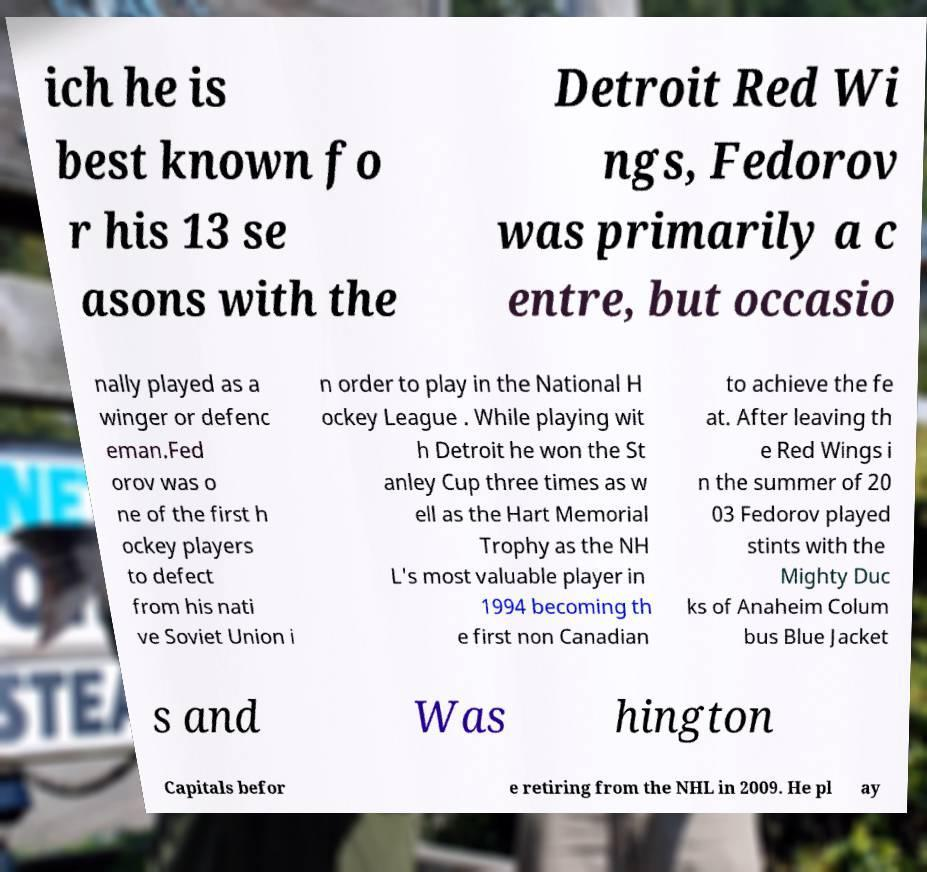What messages or text are displayed in this image? I need them in a readable, typed format. ich he is best known fo r his 13 se asons with the Detroit Red Wi ngs, Fedorov was primarily a c entre, but occasio nally played as a winger or defenc eman.Fed orov was o ne of the first h ockey players to defect from his nati ve Soviet Union i n order to play in the National H ockey League . While playing wit h Detroit he won the St anley Cup three times as w ell as the Hart Memorial Trophy as the NH L's most valuable player in 1994 becoming th e first non Canadian to achieve the fe at. After leaving th e Red Wings i n the summer of 20 03 Fedorov played stints with the Mighty Duc ks of Anaheim Colum bus Blue Jacket s and Was hington Capitals befor e retiring from the NHL in 2009. He pl ay 